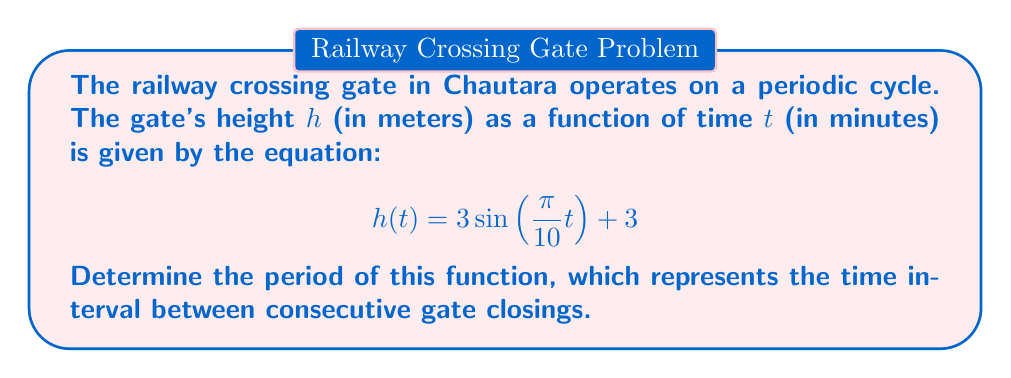Could you help me with this problem? To find the period of this sinusoidal function, we'll follow these steps:

1) The general form of a sine function is:
   $$f(t) = A\sin(Bt) + C$$
   where $B$ determines the period.

2) In our function:
   $$h(t) = 3\sin\left(\frac{\pi}{10}t\right) + 3$$
   We can identify that $B = \frac{\pi}{10}$

3) The period of a sine function is given by the formula:
   $$\text{Period} = \frac{2\pi}{|B|}$$

4) Substituting our value of $B$:
   $$\text{Period} = \frac{2\pi}{|\frac{\pi}{10}|}$$

5) Simplify:
   $$\text{Period} = \frac{2\pi}{\frac{\pi}{10}} = 2\pi \cdot \frac{10}{\pi} = 20$$

Therefore, the period of the function is 20 minutes.
Answer: 20 minutes 